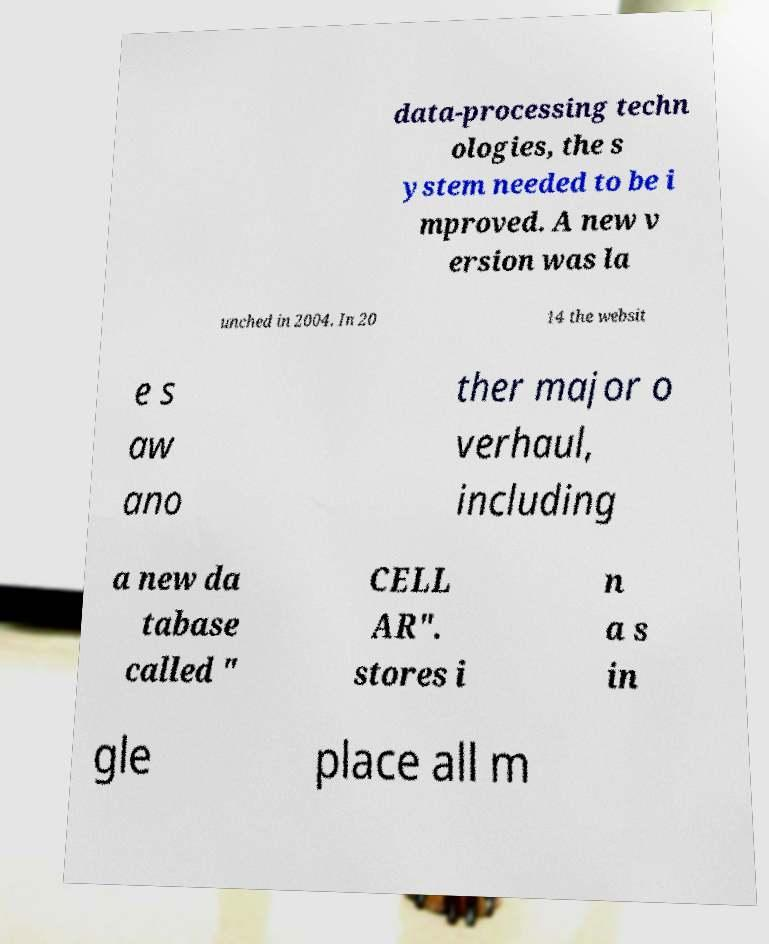Could you extract and type out the text from this image? data-processing techn ologies, the s ystem needed to be i mproved. A new v ersion was la unched in 2004. In 20 14 the websit e s aw ano ther major o verhaul, including a new da tabase called " CELL AR". stores i n a s in gle place all m 